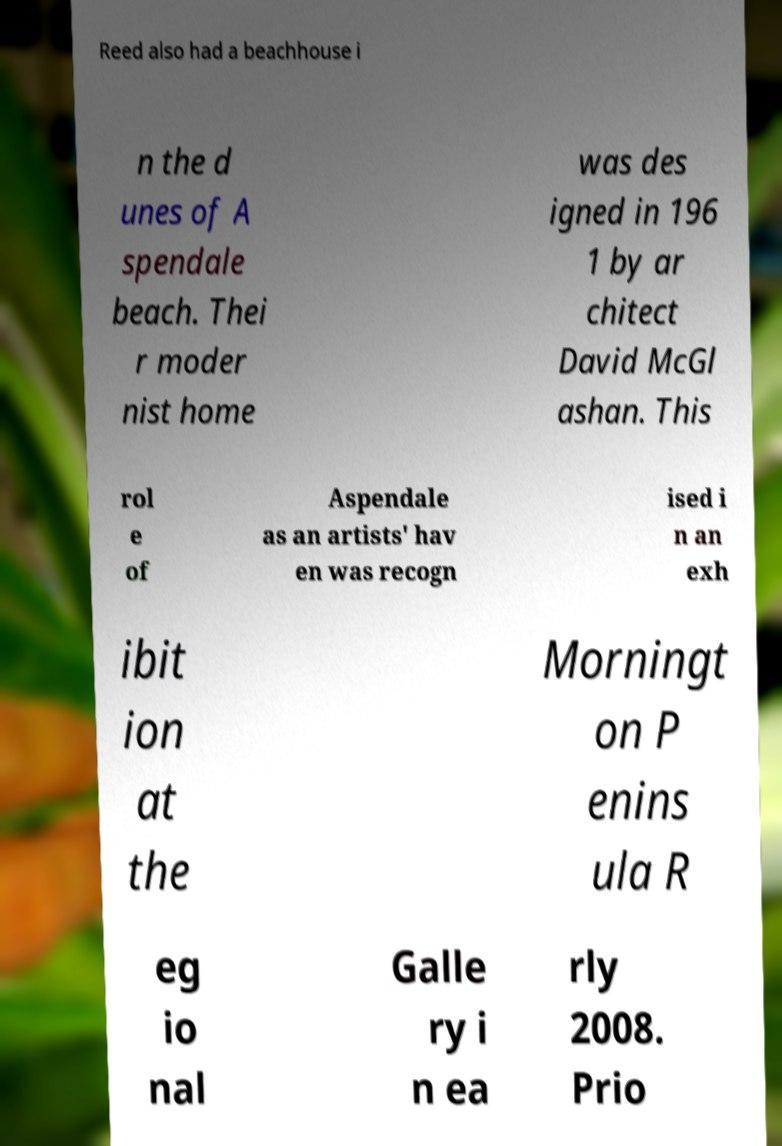What messages or text are displayed in this image? I need them in a readable, typed format. Reed also had a beachhouse i n the d unes of A spendale beach. Thei r moder nist home was des igned in 196 1 by ar chitect David McGl ashan. This rol e of Aspendale as an artists' hav en was recogn ised i n an exh ibit ion at the Morningt on P enins ula R eg io nal Galle ry i n ea rly 2008. Prio 